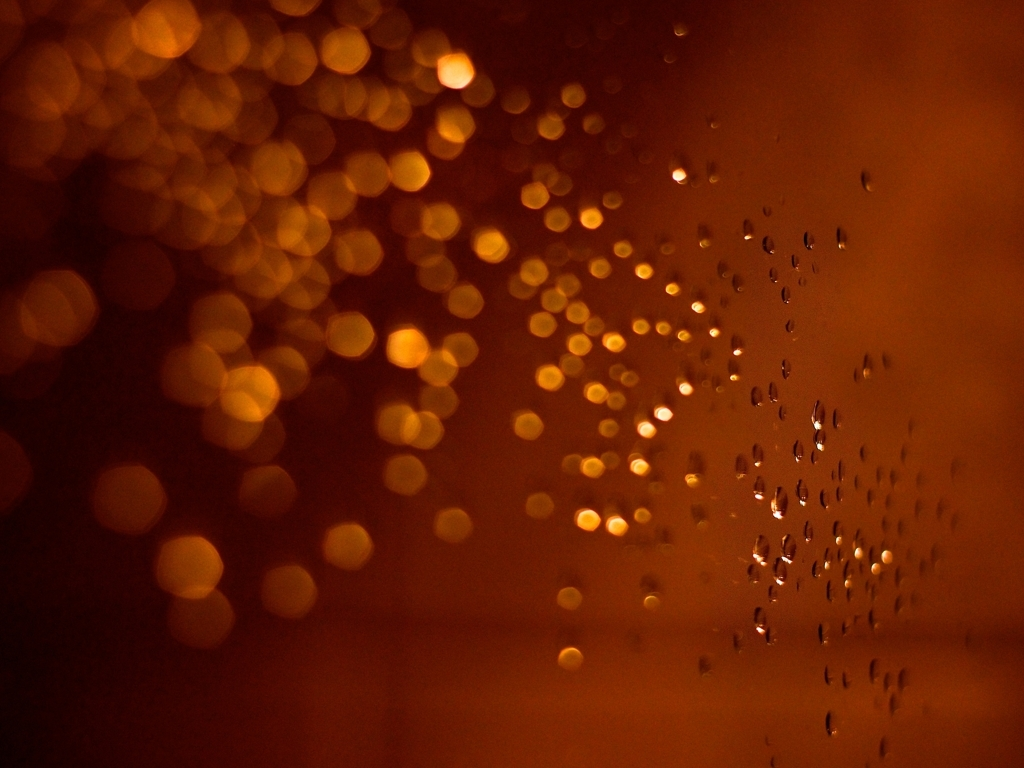What mood does this image invoke, and could you describe any possible scenarios where this setting might be? The image evokes a sense of warmth and introspection, typically associated with a calm and contemplative evening indoors. A possible scenario could be someone observing the rain through a window on a cozy evening, lost in thought or simply enjoying the tranquility of the moment. In a literary context, how might an author use this imagery in their narrative? An author might use this imagery to signify a pivotal moment of reflection for a character, perhaps symbolizing a turning point or a moment of clarity. The rain and blurred lights could serve as a metaphor for the chaos of life being momentarily put on pause, allowing the character to focus on their innermost thoughts. 